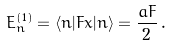<formula> <loc_0><loc_0><loc_500><loc_500>E _ { n } ^ { ( 1 ) } = \langle n | F x | n \rangle = \frac { a F } { 2 } \, .</formula> 